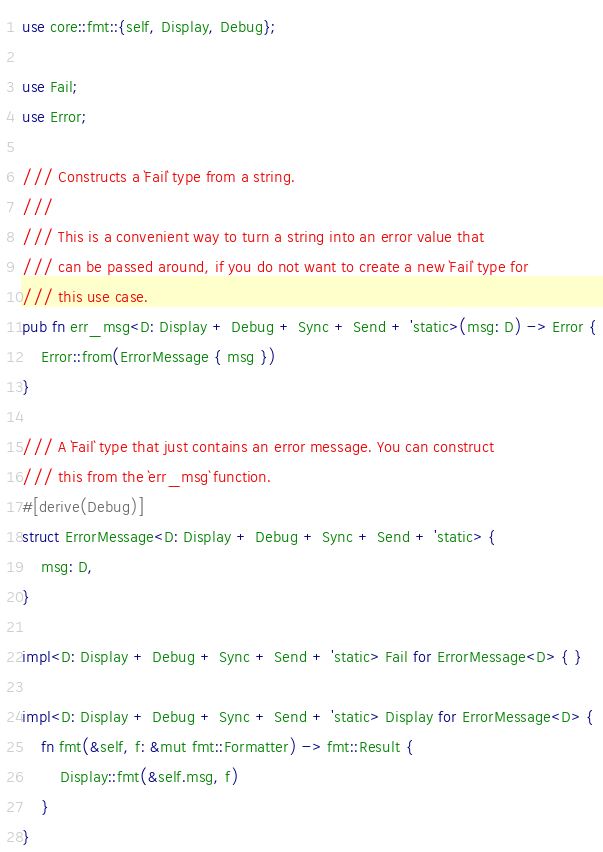<code> <loc_0><loc_0><loc_500><loc_500><_Rust_>use core::fmt::{self, Display, Debug};

use Fail;
use Error;

/// Constructs a `Fail` type from a string.
///
/// This is a convenient way to turn a string into an error value that
/// can be passed around, if you do not want to create a new `Fail` type for
/// this use case.
pub fn err_msg<D: Display + Debug + Sync + Send + 'static>(msg: D) -> Error {
    Error::from(ErrorMessage { msg })
}

/// A `Fail` type that just contains an error message. You can construct
/// this from the `err_msg` function.
#[derive(Debug)]
struct ErrorMessage<D: Display + Debug + Sync + Send + 'static> {
    msg: D,
}

impl<D: Display + Debug + Sync + Send + 'static> Fail for ErrorMessage<D> { }

impl<D: Display + Debug + Sync + Send + 'static> Display for ErrorMessage<D> {
    fn fmt(&self, f: &mut fmt::Formatter) -> fmt::Result {
        Display::fmt(&self.msg, f)
    }
}
</code> 